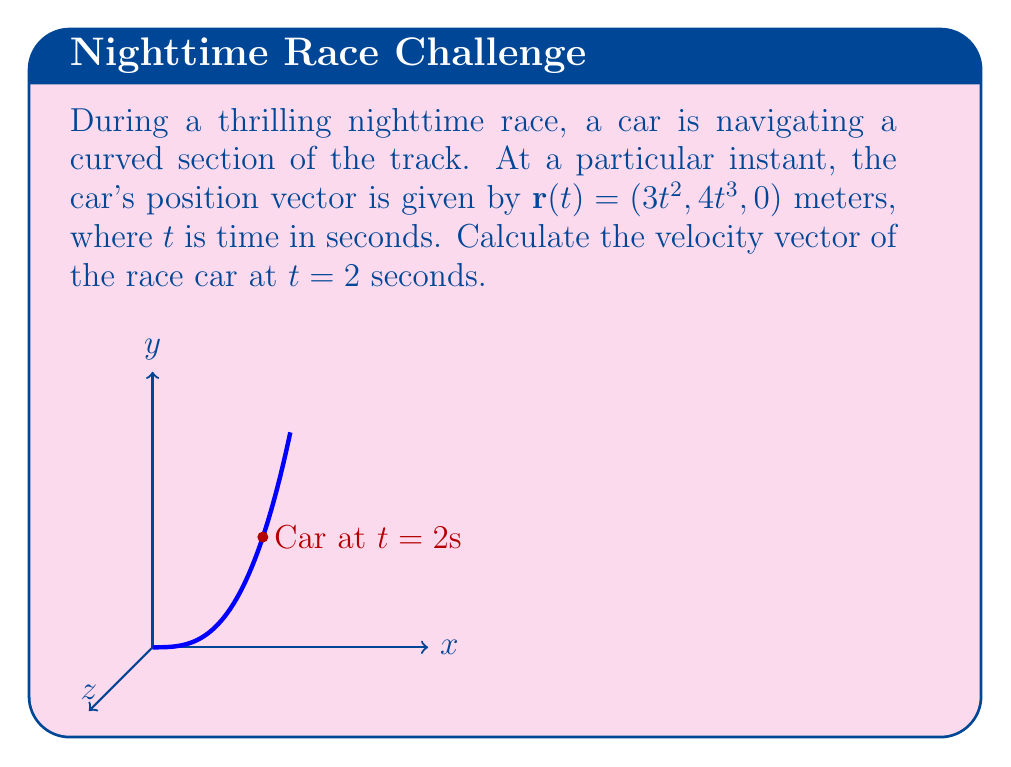Solve this math problem. To find the velocity vector, we need to differentiate the position vector with respect to time. Let's approach this step-by-step:

1) The position vector is given as $\mathbf{r}(t) = (3t^2, 4t^3, 0)$.

2) The velocity vector is the first derivative of the position vector:
   $$\mathbf{v}(t) = \frac{d\mathbf{r}}{dt} = (\frac{dx}{dt}, \frac{dy}{dt}, \frac{dz}{dt})$$

3) Let's differentiate each component:
   - $\frac{dx}{dt} = \frac{d}{dt}(3t^2) = 6t$
   - $\frac{dy}{dt} = \frac{d}{dt}(4t^3) = 12t^2$
   - $\frac{dz}{dt} = \frac{d}{dt}(0) = 0$

4) Therefore, the velocity vector is:
   $$\mathbf{v}(t) = (6t, 12t^2, 0)$$

5) We need to find the velocity at $t = 2$ seconds. Let's substitute $t = 2$:
   $$\mathbf{v}(2) = (6(2), 12(2)^2, 0) = (12, 48, 0)$$

Thus, the velocity vector of the race car at $t = 2$ seconds is $(12, 48, 0)$ meters per second.
Answer: $(12, 48, 0)$ m/s 